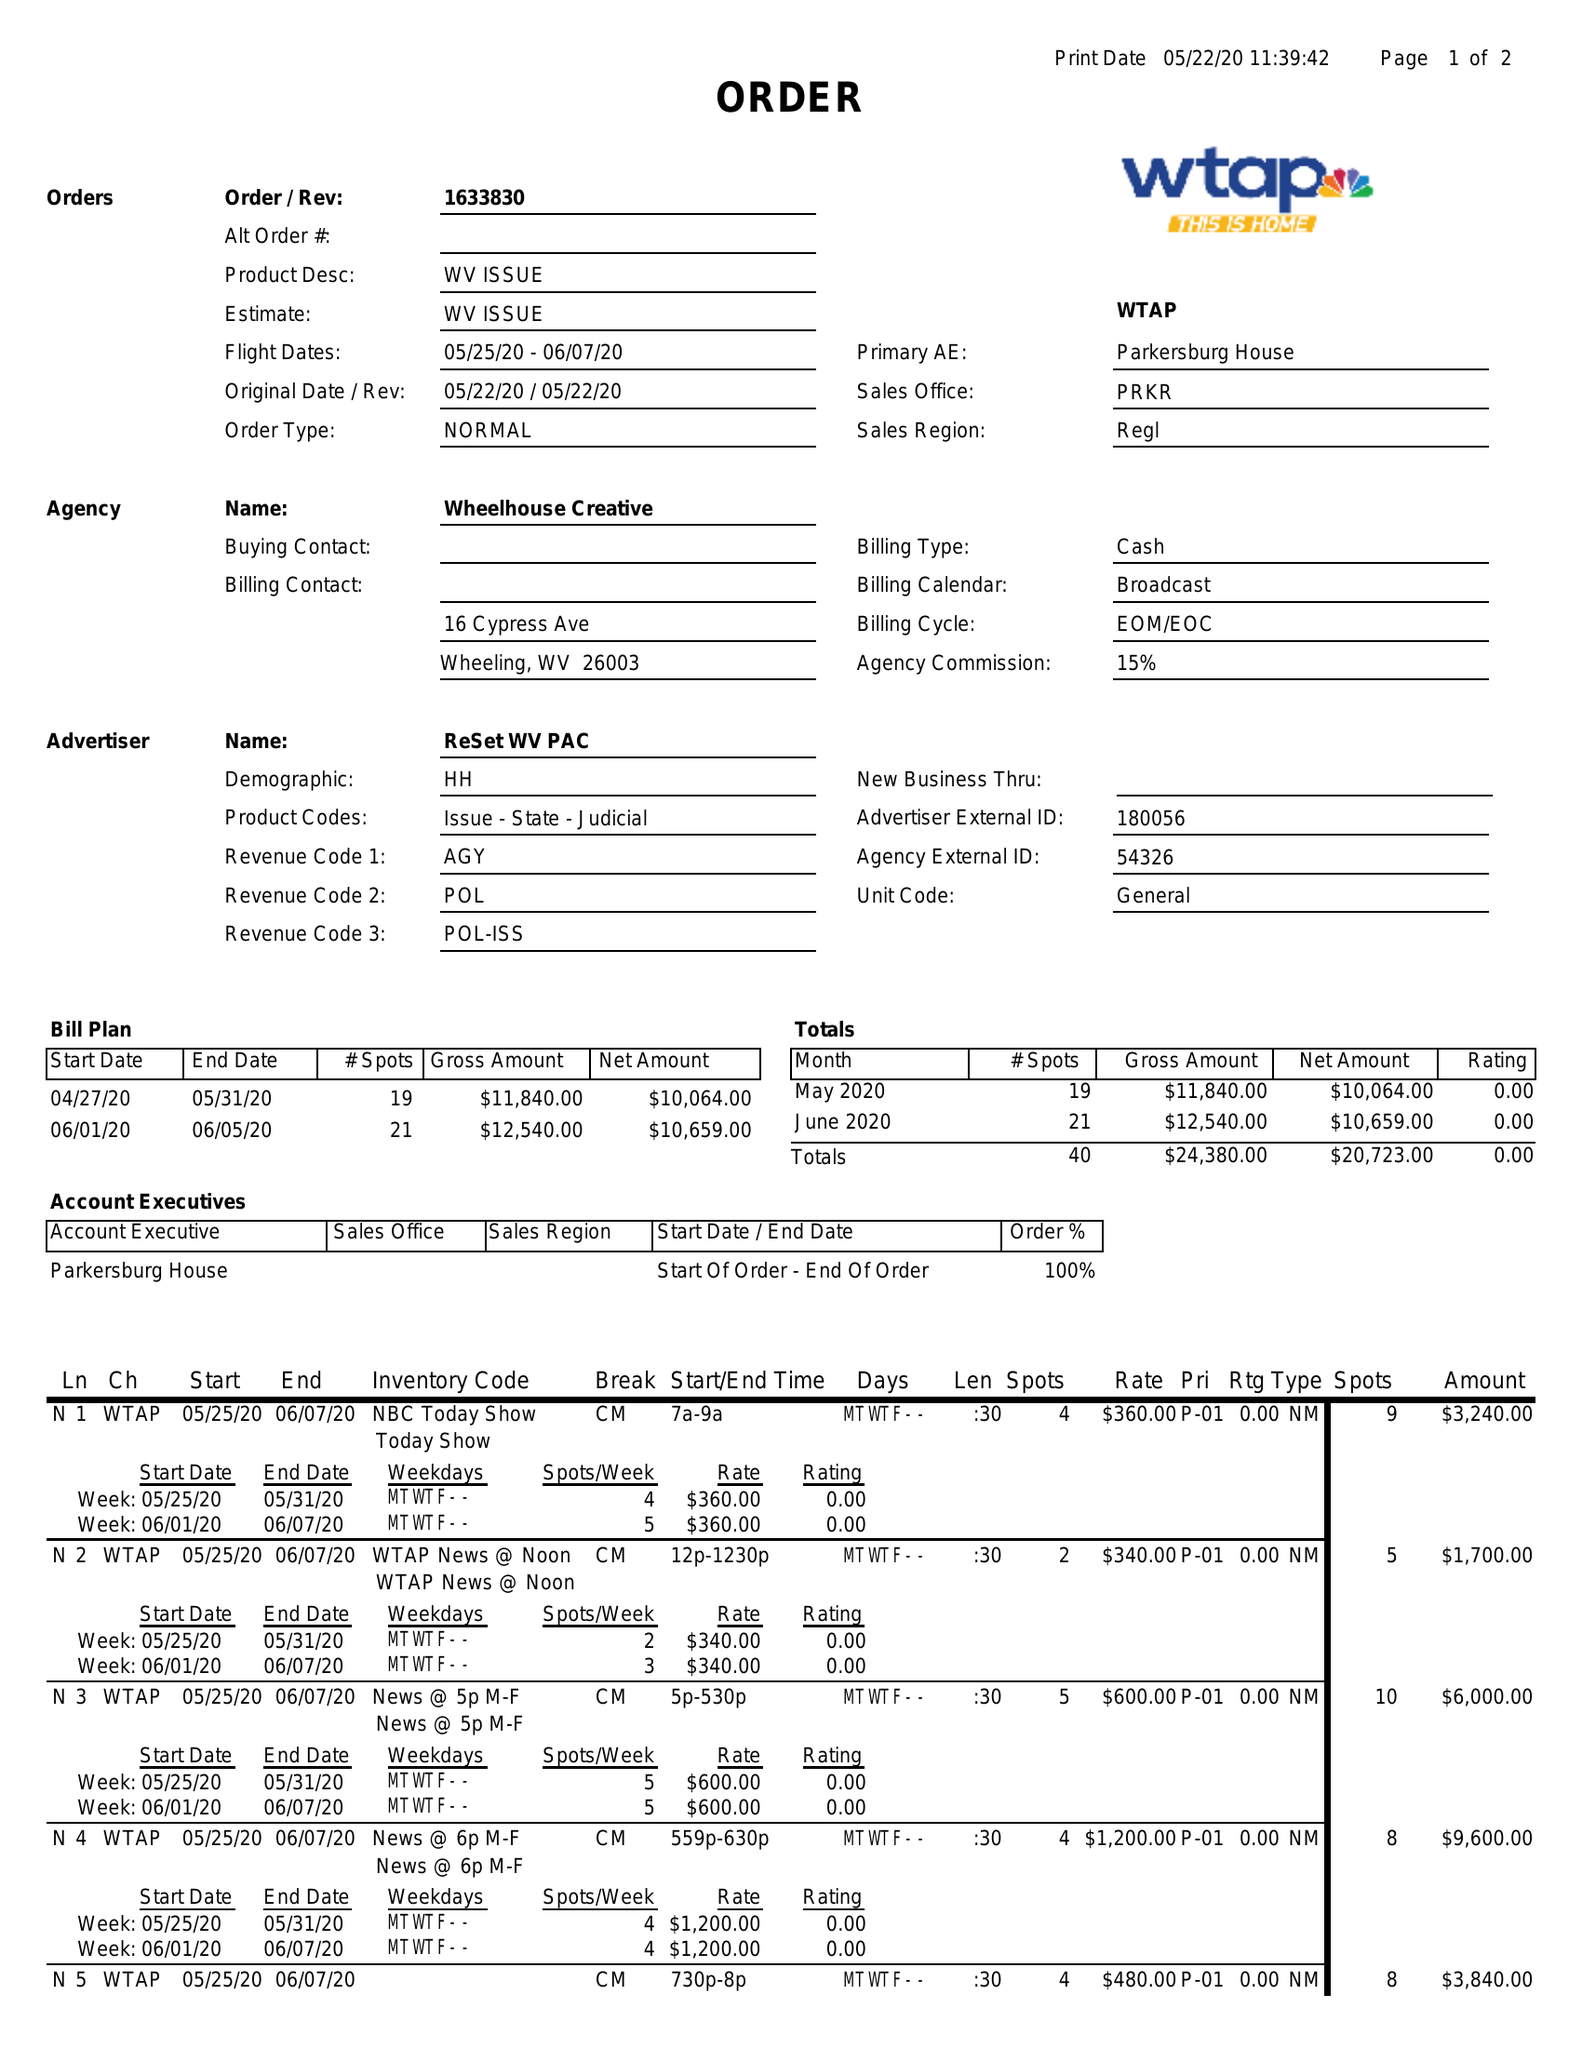What is the value for the contract_num?
Answer the question using a single word or phrase. 1633830 